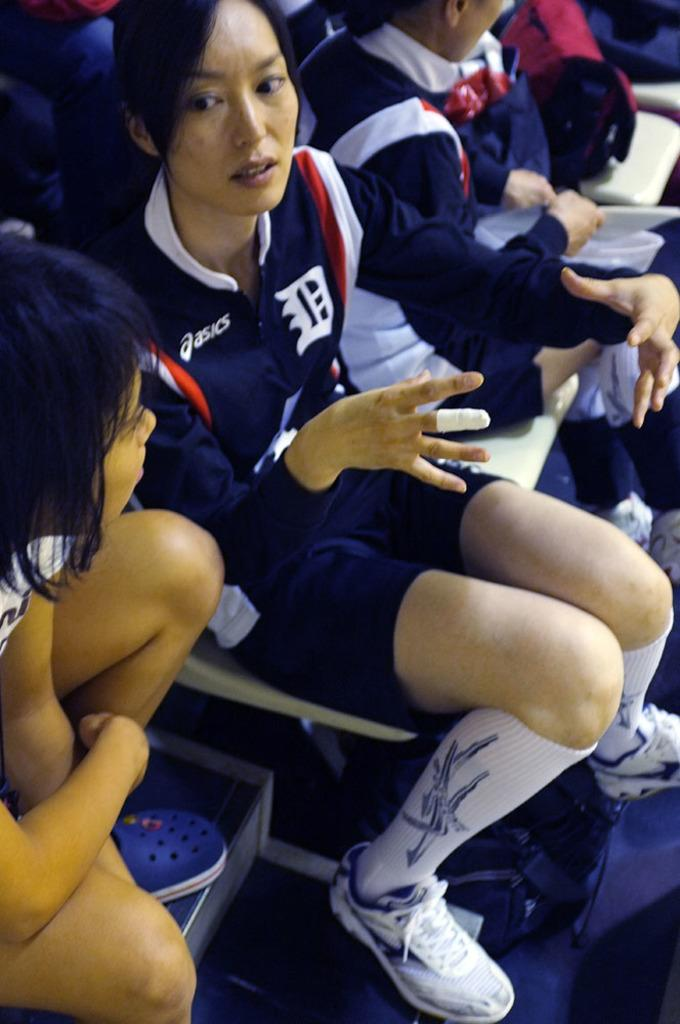<image>
Write a terse but informative summary of the picture. Players sitting with aSICS on their sweat shirts. 